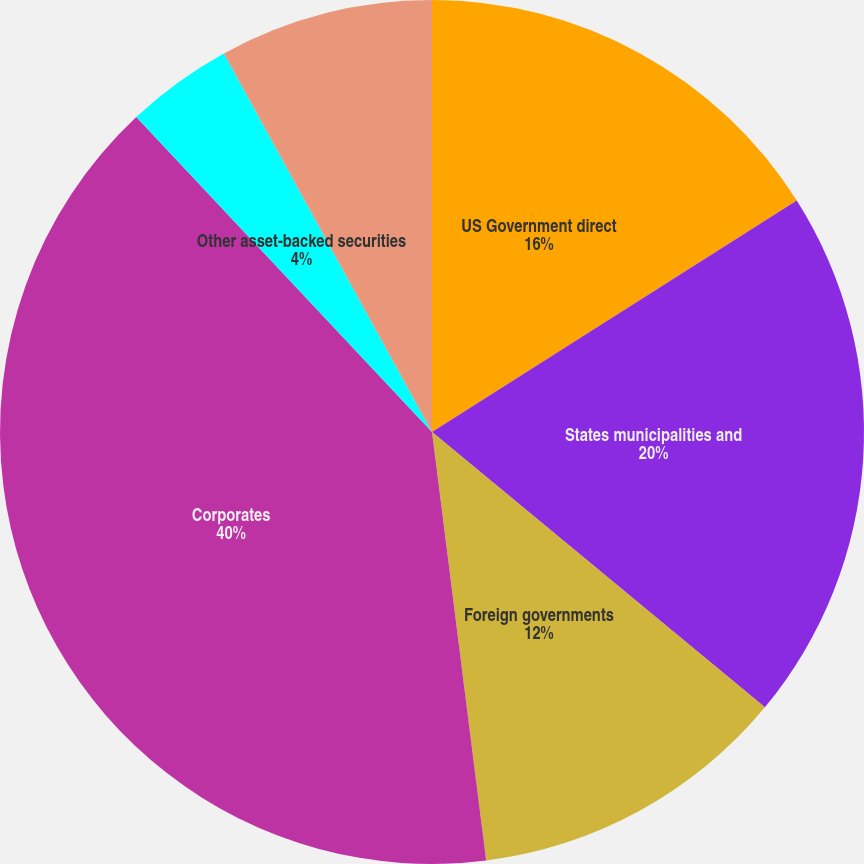Convert chart. <chart><loc_0><loc_0><loc_500><loc_500><pie_chart><fcel>US Government direct<fcel>States municipalities and<fcel>Foreign governments<fcel>Corporates<fcel>Collateralized debt<fcel>Other asset-backed securities<fcel>Redeemable preferred stocks<nl><fcel>16.0%<fcel>20.0%<fcel>12.0%<fcel>40.0%<fcel>0.0%<fcel>4.0%<fcel>8.0%<nl></chart> 